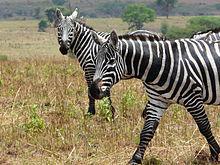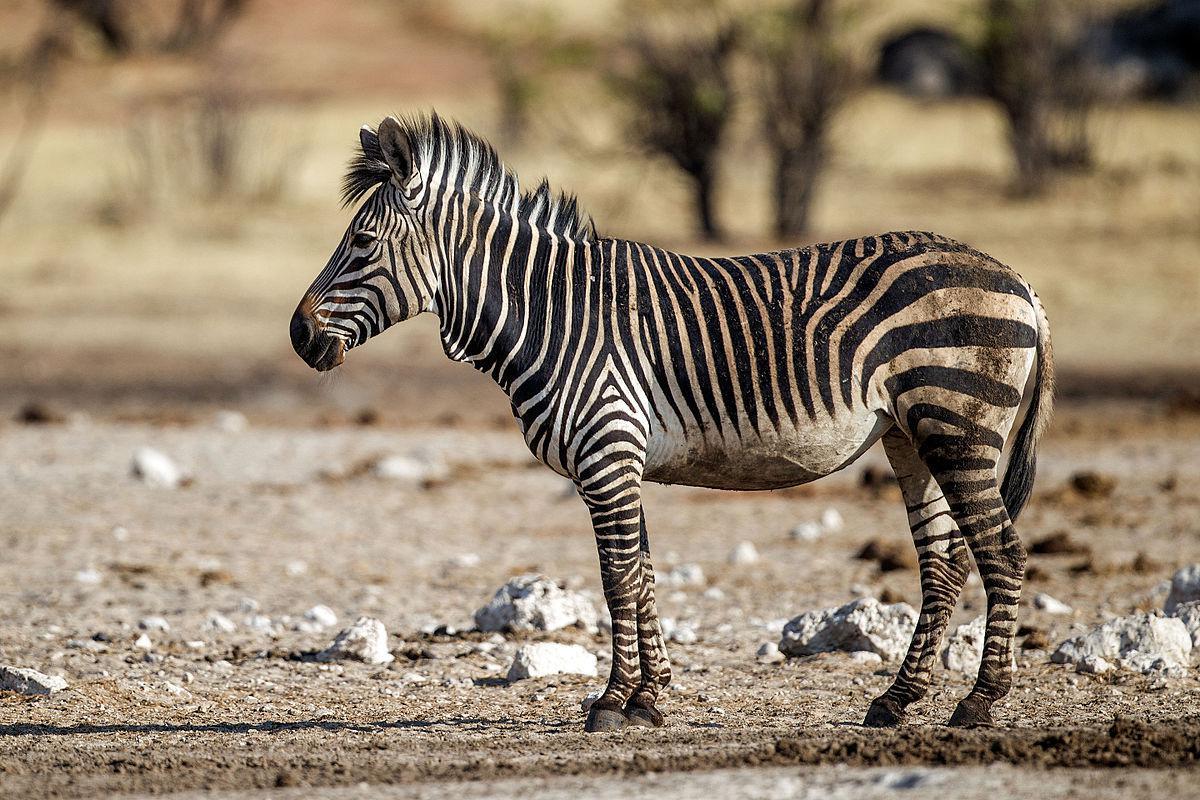The first image is the image on the left, the second image is the image on the right. Examine the images to the left and right. Is the description "An image shows a zebra with its body facing left and its snout over the back of a smaller zebra." accurate? Answer yes or no. No. The first image is the image on the left, the second image is the image on the right. For the images displayed, is the sentence "There are at least two very young zebra here." factually correct? Answer yes or no. No. 